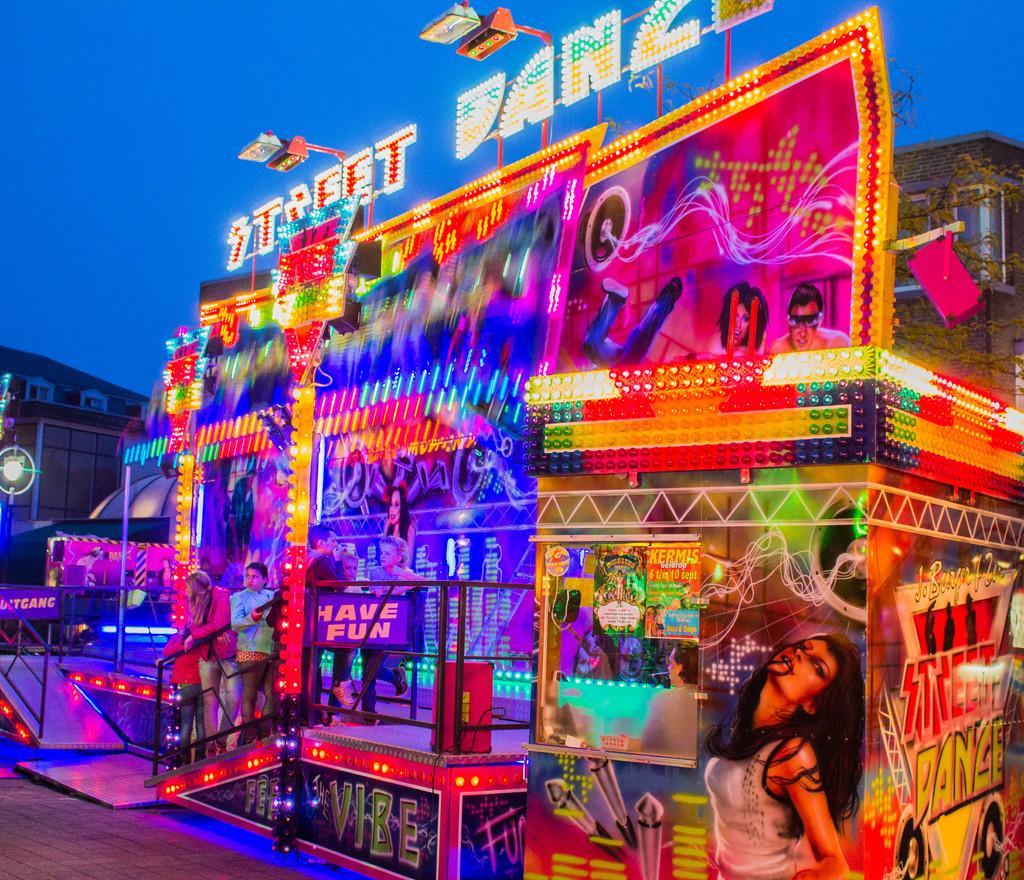Please provide a concise description of this image. In this image there is a stall. There are many boards with pictures and text on the stall. In the front there are steps and a railing. There are a few people standing on the steps. At the top of the stall there are lights. In the background there are buildings. At the top there is the sky. 